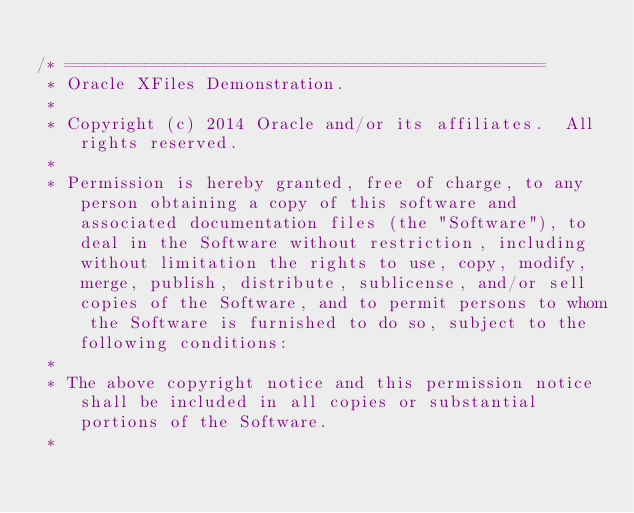<code> <loc_0><loc_0><loc_500><loc_500><_SQL_>
/* ================================================  
 * Oracle XFiles Demonstration.  
 *    
 * Copyright (c) 2014 Oracle and/or its affiliates.  All rights reserved.
 *
 * Permission is hereby granted, free of charge, to any person obtaining a copy of this software and associated documentation files (the "Software"), to deal in the Software without restriction, including without limitation the rights to use, copy, modify, merge, publish, distribute, sublicense, and/or sell copies of the Software, and to permit persons to whom the Software is furnished to do so, subject to the following conditions:
 *
 * The above copyright notice and this permission notice shall be included in all copies or substantial portions of the Software.
 *</code> 